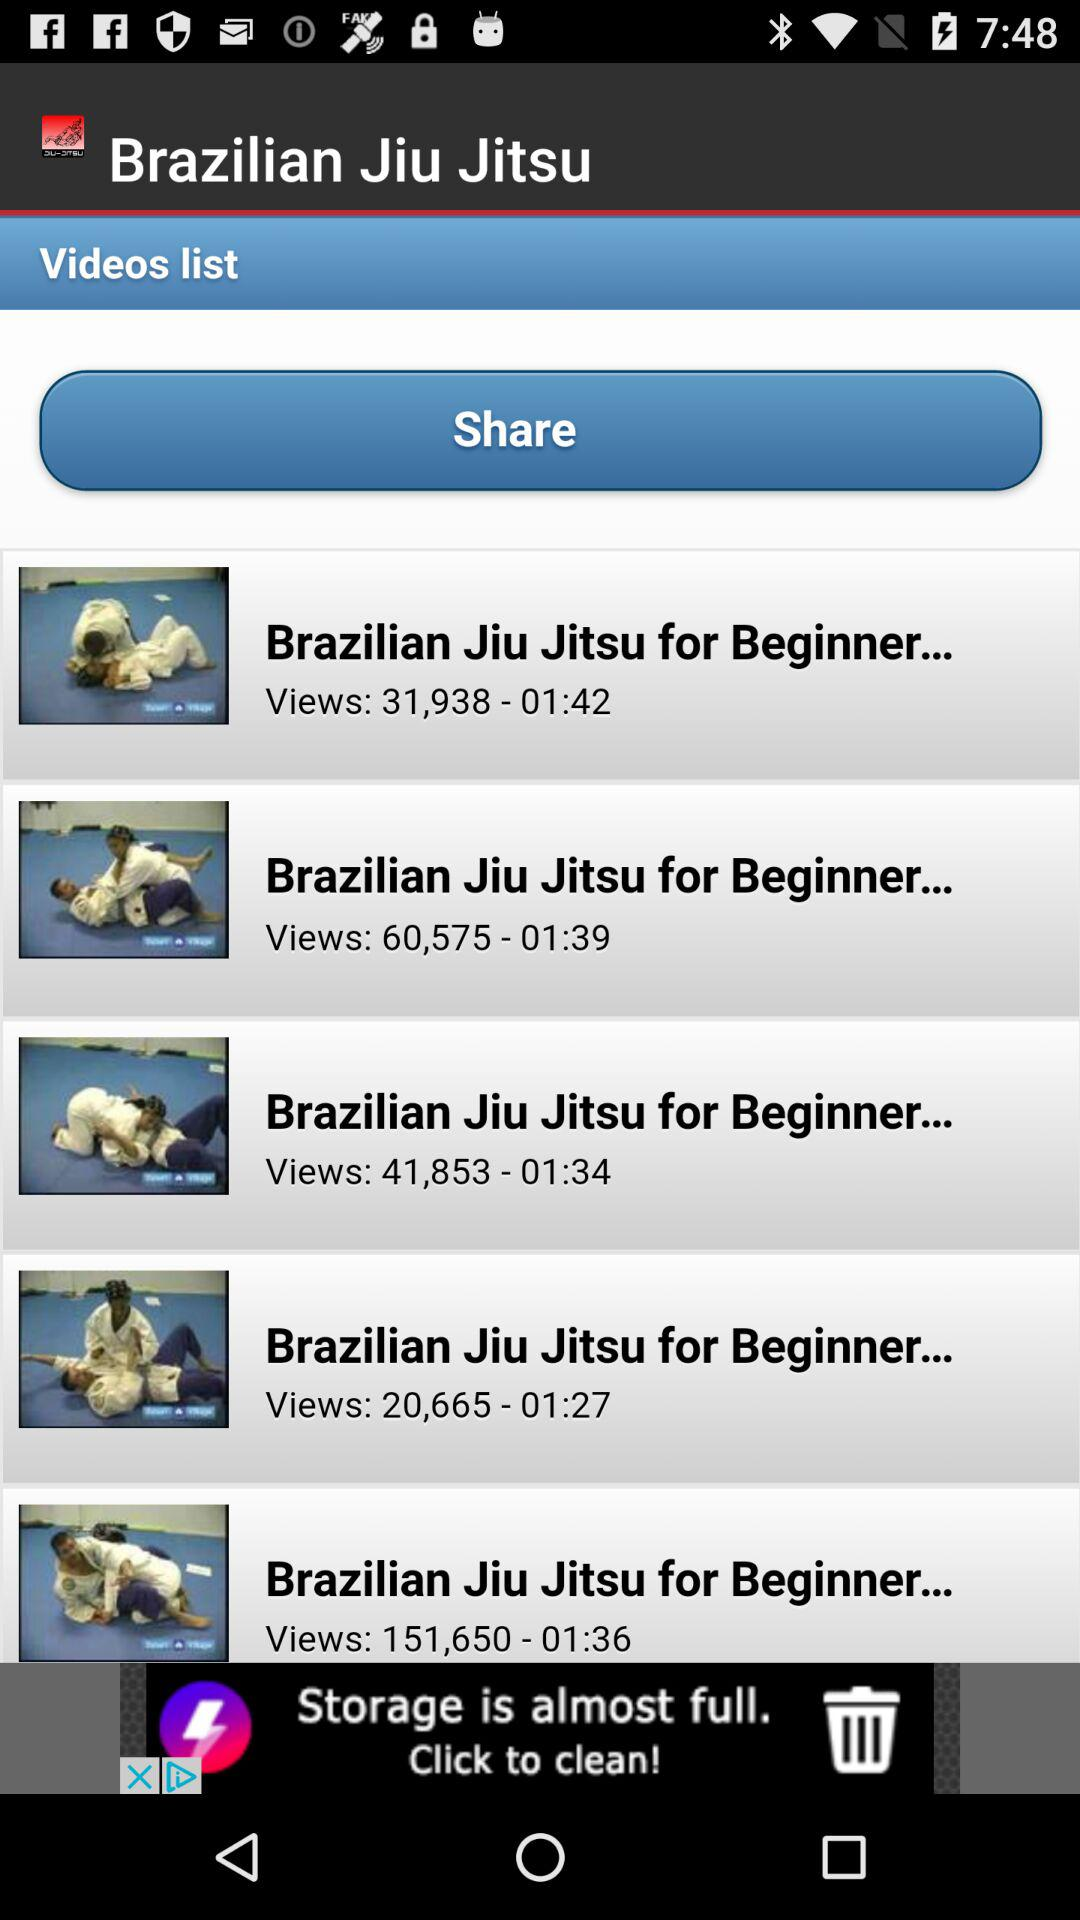How many videos are there in total?
Answer the question using a single word or phrase. 5 